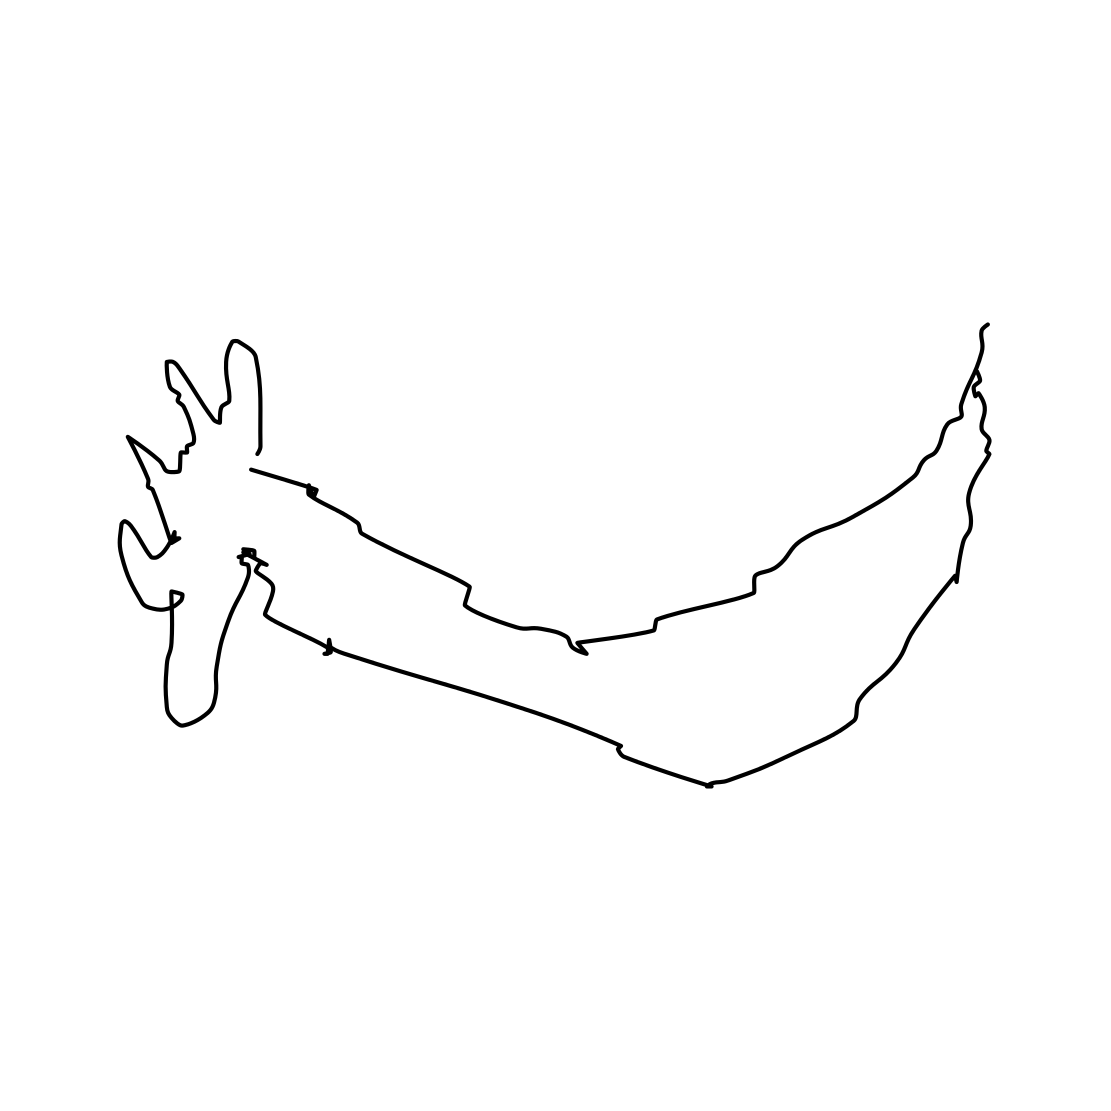Can you tell me more about what this drawing represents? This drawing represents a stylized side profile of a deer or reindeer, characterized by its large, conspicuous antlers. The simplicity of the lines suggests an artistic approach focusing on the essence and form rather than intricate detail. 